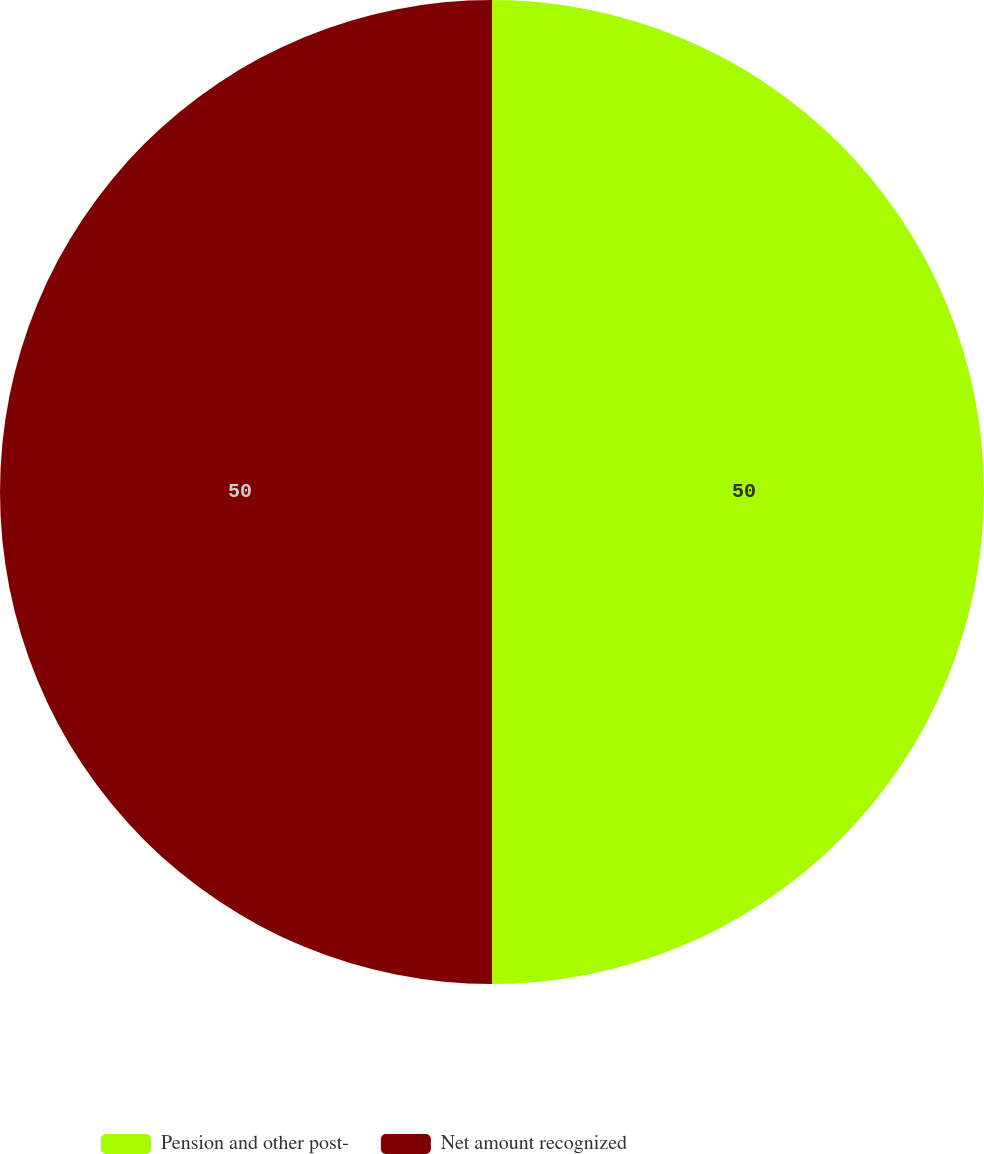Convert chart. <chart><loc_0><loc_0><loc_500><loc_500><pie_chart><fcel>Pension and other post-<fcel>Net amount recognized<nl><fcel>50.0%<fcel>50.0%<nl></chart> 